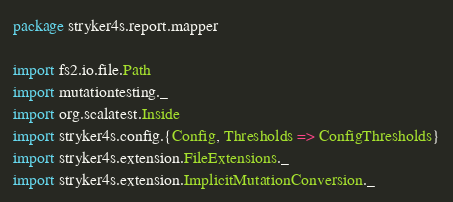<code> <loc_0><loc_0><loc_500><loc_500><_Scala_>package stryker4s.report.mapper

import fs2.io.file.Path
import mutationtesting._
import org.scalatest.Inside
import stryker4s.config.{Config, Thresholds => ConfigThresholds}
import stryker4s.extension.FileExtensions._
import stryker4s.extension.ImplicitMutationConversion._</code> 